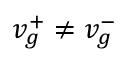<formula> <loc_0><loc_0><loc_500><loc_500>v _ { g } ^ { + } \neq v _ { g } ^ { - }</formula> 